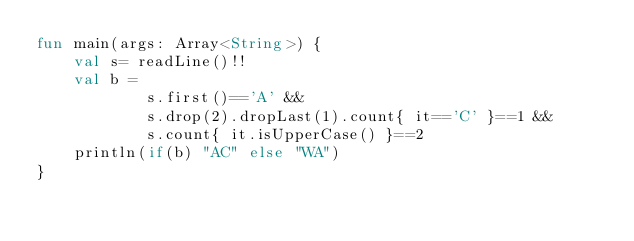Convert code to text. <code><loc_0><loc_0><loc_500><loc_500><_Kotlin_>fun main(args: Array<String>) {
    val s= readLine()!!
    val b =
            s.first()=='A' &&
            s.drop(2).dropLast(1).count{ it=='C' }==1 &&
            s.count{ it.isUpperCase() }==2
    println(if(b) "AC" else "WA")
}</code> 